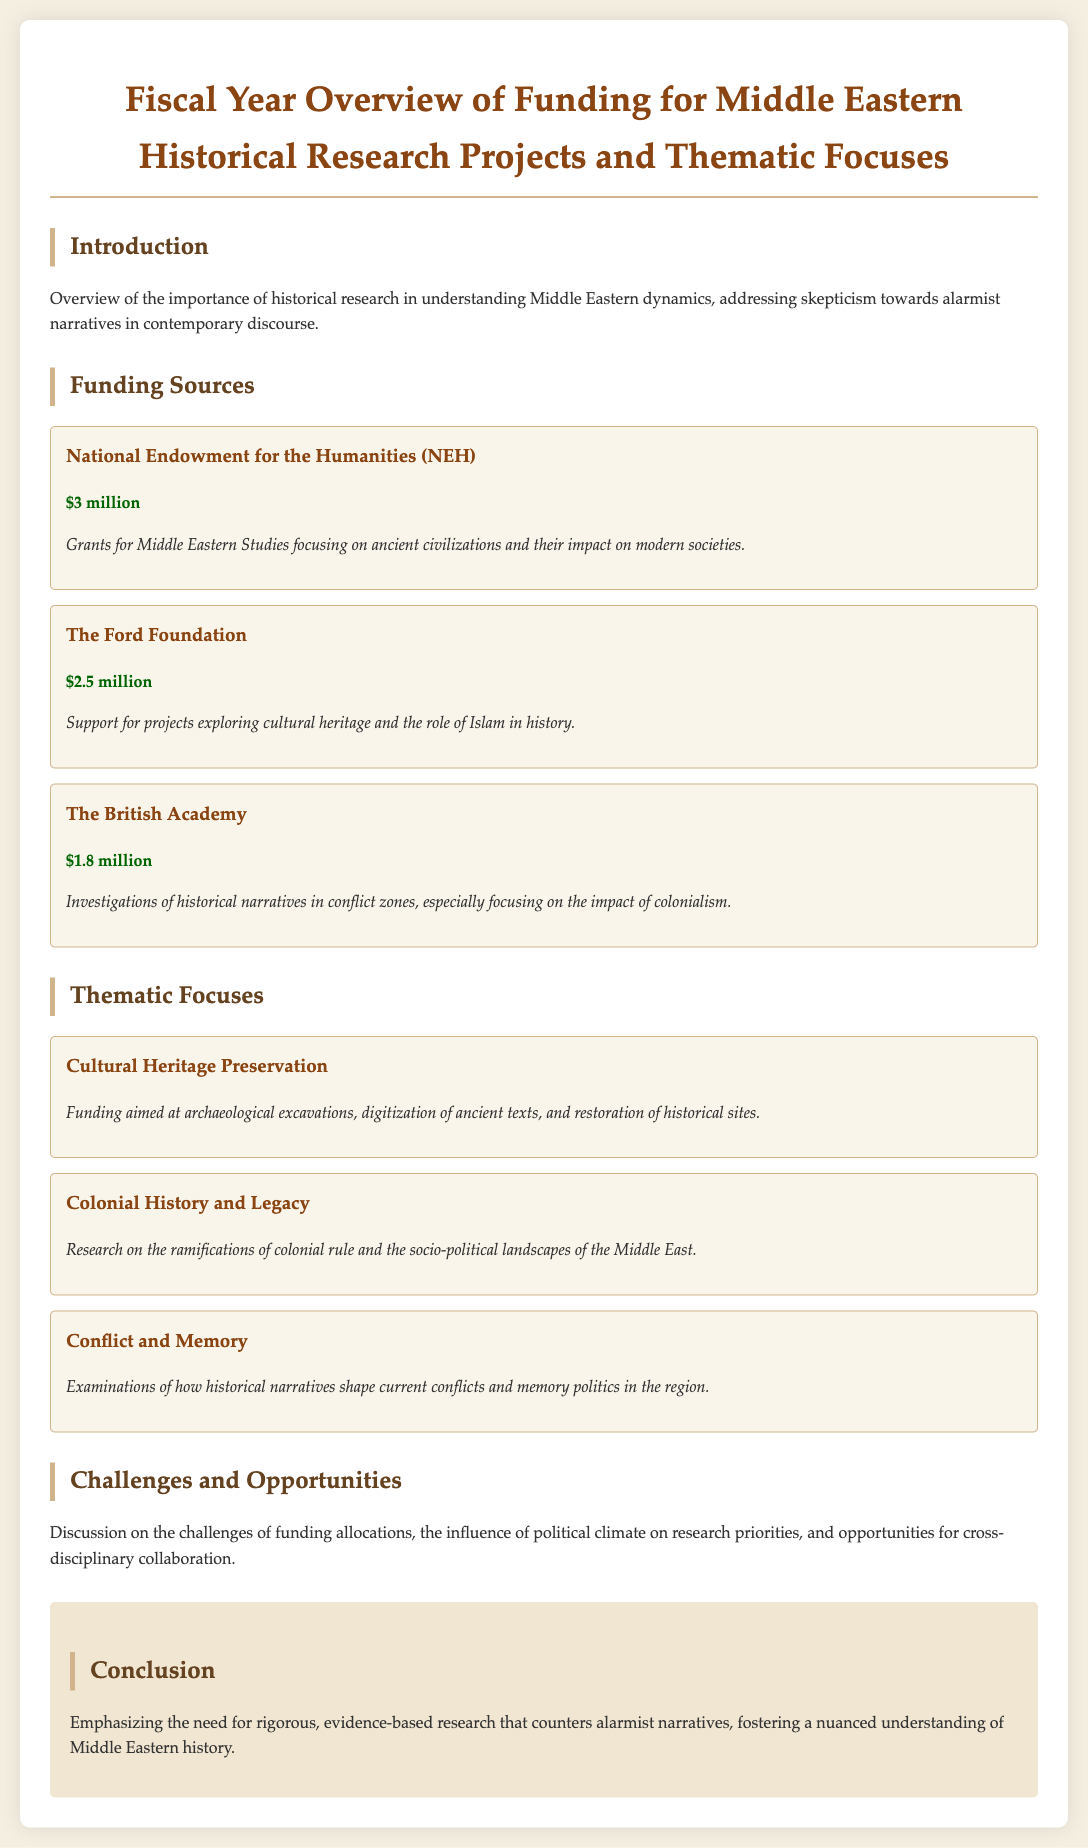what is the total funding from the National Endowment for the Humanities? The document states that the National Endowment for the Humanities is providing $3 million in funding.
Answer: $3 million what is the thematic focus related to archaeological work? The document mentions "Cultural Heritage Preservation" which includes funding for archaeological excavations.
Answer: Cultural Heritage Preservation which funding source supports the exploration of cultural heritage? The Ford Foundation supports projects exploring cultural heritage.
Answer: The Ford Foundation how much funding is allocated by The British Academy? The document states that The British Academy has allocated $1.8 million for funding.
Answer: $1.8 million what is the main challenge mentioned regarding research funding? The document discusses the challenges of funding allocations and the influence of political climate.
Answer: Funding allocations what project focus examines historical narratives in conflict zones? The document states that one focus is on "Colonial History and Legacy."
Answer: Colonial History and Legacy what is emphasized in the conclusion for understanding Middle Eastern history? The conclusion emphasizes the need for rigorous, evidence-based research.
Answer: Rigorous, evidence-based research what is the total funding amount from The Ford Foundation and The British Academy? The total funding from The Ford Foundation ($2.5 million) and The British Academy ($1.8 million) is calculated as $2.5 million + $1.8 million = $4.3 million.
Answer: $4.3 million which thematic focus addresses memory politics? The document states that "Conflict and Memory" examines how historical narratives shape current conflicts.
Answer: Conflict and Memory 